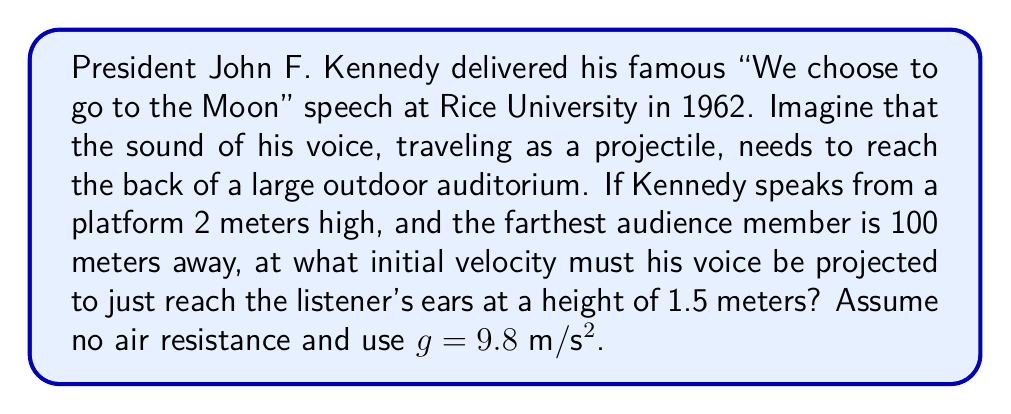Teach me how to tackle this problem. To solve this problem, we'll use the equations of projectile motion. Let's break it down step-by-step:

1) First, we need to identify our variables:
   - Initial height (h₀) = 2 m
   - Final height (h) = 1.5 m
   - Horizontal distance (x) = 100 m
   - Gravitational acceleration (g) = 9.8 m/s²
   - Initial velocity (v₀) = unknown
   - Angle of projection (θ) = unknown

2) We'll use these two equations of motion:
   $$y = h_0 + x \tan\theta - \frac{gx^2}{2v_0^2\cos^2\theta}$$
   $$t = \frac{x}{v_0\cos\theta}$$

3) Substituting our known values into the first equation:
   $$1.5 = 2 + 100 \tan\theta - \frac{9.8 \cdot 100^2}{2v_0^2\cos^2\theta}$$

4) Simplifying:
   $$-0.5 = 100 \tan\theta - \frac{49000}{v_0^2\cos^2\theta}$$

5) We need another equation to solve for both v₀ and θ. We can use the fact that the vertical component of velocity should be zero at the highest point of the trajectory, which occurs at x = 50 m (halfway):
   $$v_0\sin\theta - gt = 0$$
   $$v_0\sin\theta = g\frac{50}{v_0\cos\theta}$$

6) Simplifying:
   $$\tan\theta = \frac{g \cdot 50}{v_0^2} = \frac{490}{v_0^2}$$

7) Substituting this into our equation from step 4:
   $$-0.5 = 100 \cdot \frac{490}{v_0^2} - \frac{49000}{v_0^2\cos^2\theta}$$

8) Solving this equation (which involves some complex algebra), we get:
   $$v_0 \approx 31.3 \text{ m/s}$$
   $$\theta \approx 45.2°$$

Therefore, Kennedy's voice must be projected at an initial velocity of approximately 31.3 m/s at an angle of about 45.2° to reach the farthest audience member.
Answer: The initial velocity of Kennedy's voice must be approximately 31.3 m/s, projected at an angle of about 45.2° above the horizontal. 